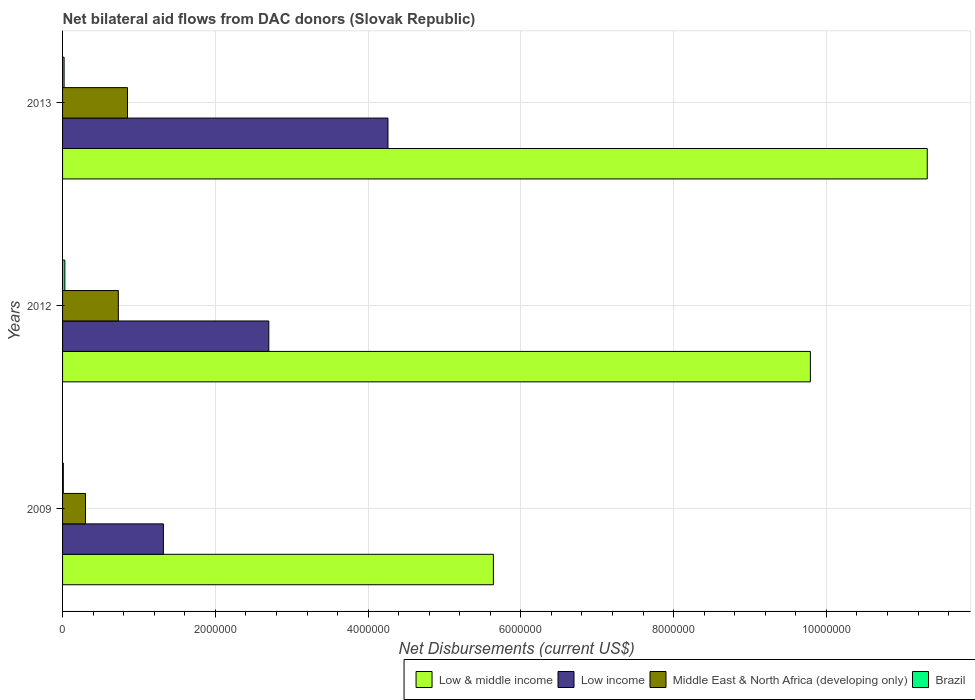How many different coloured bars are there?
Offer a very short reply. 4. Are the number of bars per tick equal to the number of legend labels?
Your answer should be compact. Yes. Are the number of bars on each tick of the Y-axis equal?
Ensure brevity in your answer.  Yes. How many bars are there on the 3rd tick from the bottom?
Keep it short and to the point. 4. In how many cases, is the number of bars for a given year not equal to the number of legend labels?
Keep it short and to the point. 0. What is the net bilateral aid flows in Low & middle income in 2012?
Offer a terse response. 9.79e+06. Across all years, what is the maximum net bilateral aid flows in Middle East & North Africa (developing only)?
Provide a short and direct response. 8.50e+05. Across all years, what is the minimum net bilateral aid flows in Low & middle income?
Your answer should be very brief. 5.64e+06. What is the total net bilateral aid flows in Low & middle income in the graph?
Provide a short and direct response. 2.68e+07. What is the difference between the net bilateral aid flows in Middle East & North Africa (developing only) in 2009 and that in 2013?
Your response must be concise. -5.50e+05. What is the difference between the net bilateral aid flows in Middle East & North Africa (developing only) in 2009 and the net bilateral aid flows in Brazil in 2013?
Provide a succinct answer. 2.80e+05. What is the average net bilateral aid flows in Low & middle income per year?
Offer a very short reply. 8.92e+06. In the year 2013, what is the difference between the net bilateral aid flows in Middle East & North Africa (developing only) and net bilateral aid flows in Low income?
Your answer should be compact. -3.41e+06. In how many years, is the net bilateral aid flows in Middle East & North Africa (developing only) greater than 9600000 US$?
Give a very brief answer. 0. What is the ratio of the net bilateral aid flows in Low income in 2009 to that in 2012?
Keep it short and to the point. 0.49. Is the net bilateral aid flows in Low income in 2009 less than that in 2013?
Offer a very short reply. Yes. What is the difference between the highest and the second highest net bilateral aid flows in Low income?
Provide a succinct answer. 1.56e+06. What is the difference between the highest and the lowest net bilateral aid flows in Low income?
Offer a terse response. 2.94e+06. In how many years, is the net bilateral aid flows in Middle East & North Africa (developing only) greater than the average net bilateral aid flows in Middle East & North Africa (developing only) taken over all years?
Offer a very short reply. 2. Is the sum of the net bilateral aid flows in Low & middle income in 2012 and 2013 greater than the maximum net bilateral aid flows in Middle East & North Africa (developing only) across all years?
Make the answer very short. Yes. What does the 4th bar from the bottom in 2013 represents?
Offer a very short reply. Brazil. Is it the case that in every year, the sum of the net bilateral aid flows in Middle East & North Africa (developing only) and net bilateral aid flows in Low income is greater than the net bilateral aid flows in Low & middle income?
Make the answer very short. No. How many bars are there?
Ensure brevity in your answer.  12. Are all the bars in the graph horizontal?
Your answer should be compact. Yes. What is the difference between two consecutive major ticks on the X-axis?
Your answer should be compact. 2.00e+06. Are the values on the major ticks of X-axis written in scientific E-notation?
Offer a terse response. No. Does the graph contain any zero values?
Offer a very short reply. No. Does the graph contain grids?
Provide a succinct answer. Yes. Where does the legend appear in the graph?
Offer a very short reply. Bottom right. What is the title of the graph?
Offer a very short reply. Net bilateral aid flows from DAC donors (Slovak Republic). Does "Bahrain" appear as one of the legend labels in the graph?
Provide a short and direct response. No. What is the label or title of the X-axis?
Offer a terse response. Net Disbursements (current US$). What is the Net Disbursements (current US$) of Low & middle income in 2009?
Provide a succinct answer. 5.64e+06. What is the Net Disbursements (current US$) in Low income in 2009?
Make the answer very short. 1.32e+06. What is the Net Disbursements (current US$) of Middle East & North Africa (developing only) in 2009?
Give a very brief answer. 3.00e+05. What is the Net Disbursements (current US$) in Low & middle income in 2012?
Make the answer very short. 9.79e+06. What is the Net Disbursements (current US$) of Low income in 2012?
Make the answer very short. 2.70e+06. What is the Net Disbursements (current US$) in Middle East & North Africa (developing only) in 2012?
Offer a terse response. 7.30e+05. What is the Net Disbursements (current US$) of Low & middle income in 2013?
Offer a terse response. 1.13e+07. What is the Net Disbursements (current US$) of Low income in 2013?
Give a very brief answer. 4.26e+06. What is the Net Disbursements (current US$) of Middle East & North Africa (developing only) in 2013?
Provide a succinct answer. 8.50e+05. Across all years, what is the maximum Net Disbursements (current US$) in Low & middle income?
Offer a terse response. 1.13e+07. Across all years, what is the maximum Net Disbursements (current US$) in Low income?
Your response must be concise. 4.26e+06. Across all years, what is the maximum Net Disbursements (current US$) in Middle East & North Africa (developing only)?
Offer a very short reply. 8.50e+05. Across all years, what is the minimum Net Disbursements (current US$) in Low & middle income?
Ensure brevity in your answer.  5.64e+06. Across all years, what is the minimum Net Disbursements (current US$) in Low income?
Keep it short and to the point. 1.32e+06. Across all years, what is the minimum Net Disbursements (current US$) in Brazil?
Your answer should be very brief. 10000. What is the total Net Disbursements (current US$) in Low & middle income in the graph?
Your answer should be compact. 2.68e+07. What is the total Net Disbursements (current US$) in Low income in the graph?
Keep it short and to the point. 8.28e+06. What is the total Net Disbursements (current US$) of Middle East & North Africa (developing only) in the graph?
Offer a terse response. 1.88e+06. What is the difference between the Net Disbursements (current US$) in Low & middle income in 2009 and that in 2012?
Your answer should be compact. -4.15e+06. What is the difference between the Net Disbursements (current US$) of Low income in 2009 and that in 2012?
Offer a terse response. -1.38e+06. What is the difference between the Net Disbursements (current US$) of Middle East & North Africa (developing only) in 2009 and that in 2012?
Offer a very short reply. -4.30e+05. What is the difference between the Net Disbursements (current US$) in Brazil in 2009 and that in 2012?
Ensure brevity in your answer.  -2.00e+04. What is the difference between the Net Disbursements (current US$) of Low & middle income in 2009 and that in 2013?
Keep it short and to the point. -5.68e+06. What is the difference between the Net Disbursements (current US$) of Low income in 2009 and that in 2013?
Ensure brevity in your answer.  -2.94e+06. What is the difference between the Net Disbursements (current US$) in Middle East & North Africa (developing only) in 2009 and that in 2013?
Offer a terse response. -5.50e+05. What is the difference between the Net Disbursements (current US$) in Low & middle income in 2012 and that in 2013?
Your answer should be compact. -1.53e+06. What is the difference between the Net Disbursements (current US$) of Low income in 2012 and that in 2013?
Your response must be concise. -1.56e+06. What is the difference between the Net Disbursements (current US$) of Middle East & North Africa (developing only) in 2012 and that in 2013?
Provide a short and direct response. -1.20e+05. What is the difference between the Net Disbursements (current US$) in Low & middle income in 2009 and the Net Disbursements (current US$) in Low income in 2012?
Make the answer very short. 2.94e+06. What is the difference between the Net Disbursements (current US$) in Low & middle income in 2009 and the Net Disbursements (current US$) in Middle East & North Africa (developing only) in 2012?
Provide a short and direct response. 4.91e+06. What is the difference between the Net Disbursements (current US$) in Low & middle income in 2009 and the Net Disbursements (current US$) in Brazil in 2012?
Your response must be concise. 5.61e+06. What is the difference between the Net Disbursements (current US$) of Low income in 2009 and the Net Disbursements (current US$) of Middle East & North Africa (developing only) in 2012?
Give a very brief answer. 5.90e+05. What is the difference between the Net Disbursements (current US$) of Low income in 2009 and the Net Disbursements (current US$) of Brazil in 2012?
Offer a very short reply. 1.29e+06. What is the difference between the Net Disbursements (current US$) in Low & middle income in 2009 and the Net Disbursements (current US$) in Low income in 2013?
Your answer should be compact. 1.38e+06. What is the difference between the Net Disbursements (current US$) in Low & middle income in 2009 and the Net Disbursements (current US$) in Middle East & North Africa (developing only) in 2013?
Keep it short and to the point. 4.79e+06. What is the difference between the Net Disbursements (current US$) of Low & middle income in 2009 and the Net Disbursements (current US$) of Brazil in 2013?
Your answer should be compact. 5.62e+06. What is the difference between the Net Disbursements (current US$) of Low income in 2009 and the Net Disbursements (current US$) of Middle East & North Africa (developing only) in 2013?
Your answer should be very brief. 4.70e+05. What is the difference between the Net Disbursements (current US$) of Low income in 2009 and the Net Disbursements (current US$) of Brazil in 2013?
Make the answer very short. 1.30e+06. What is the difference between the Net Disbursements (current US$) of Low & middle income in 2012 and the Net Disbursements (current US$) of Low income in 2013?
Offer a terse response. 5.53e+06. What is the difference between the Net Disbursements (current US$) of Low & middle income in 2012 and the Net Disbursements (current US$) of Middle East & North Africa (developing only) in 2013?
Your response must be concise. 8.94e+06. What is the difference between the Net Disbursements (current US$) in Low & middle income in 2012 and the Net Disbursements (current US$) in Brazil in 2013?
Provide a short and direct response. 9.77e+06. What is the difference between the Net Disbursements (current US$) in Low income in 2012 and the Net Disbursements (current US$) in Middle East & North Africa (developing only) in 2013?
Your response must be concise. 1.85e+06. What is the difference between the Net Disbursements (current US$) of Low income in 2012 and the Net Disbursements (current US$) of Brazil in 2013?
Provide a short and direct response. 2.68e+06. What is the difference between the Net Disbursements (current US$) of Middle East & North Africa (developing only) in 2012 and the Net Disbursements (current US$) of Brazil in 2013?
Provide a short and direct response. 7.10e+05. What is the average Net Disbursements (current US$) of Low & middle income per year?
Ensure brevity in your answer.  8.92e+06. What is the average Net Disbursements (current US$) in Low income per year?
Your response must be concise. 2.76e+06. What is the average Net Disbursements (current US$) in Middle East & North Africa (developing only) per year?
Your answer should be compact. 6.27e+05. In the year 2009, what is the difference between the Net Disbursements (current US$) of Low & middle income and Net Disbursements (current US$) of Low income?
Make the answer very short. 4.32e+06. In the year 2009, what is the difference between the Net Disbursements (current US$) in Low & middle income and Net Disbursements (current US$) in Middle East & North Africa (developing only)?
Keep it short and to the point. 5.34e+06. In the year 2009, what is the difference between the Net Disbursements (current US$) in Low & middle income and Net Disbursements (current US$) in Brazil?
Ensure brevity in your answer.  5.63e+06. In the year 2009, what is the difference between the Net Disbursements (current US$) in Low income and Net Disbursements (current US$) in Middle East & North Africa (developing only)?
Offer a very short reply. 1.02e+06. In the year 2009, what is the difference between the Net Disbursements (current US$) of Low income and Net Disbursements (current US$) of Brazil?
Ensure brevity in your answer.  1.31e+06. In the year 2012, what is the difference between the Net Disbursements (current US$) of Low & middle income and Net Disbursements (current US$) of Low income?
Keep it short and to the point. 7.09e+06. In the year 2012, what is the difference between the Net Disbursements (current US$) of Low & middle income and Net Disbursements (current US$) of Middle East & North Africa (developing only)?
Offer a very short reply. 9.06e+06. In the year 2012, what is the difference between the Net Disbursements (current US$) in Low & middle income and Net Disbursements (current US$) in Brazil?
Give a very brief answer. 9.76e+06. In the year 2012, what is the difference between the Net Disbursements (current US$) in Low income and Net Disbursements (current US$) in Middle East & North Africa (developing only)?
Your response must be concise. 1.97e+06. In the year 2012, what is the difference between the Net Disbursements (current US$) of Low income and Net Disbursements (current US$) of Brazil?
Keep it short and to the point. 2.67e+06. In the year 2013, what is the difference between the Net Disbursements (current US$) of Low & middle income and Net Disbursements (current US$) of Low income?
Provide a short and direct response. 7.06e+06. In the year 2013, what is the difference between the Net Disbursements (current US$) of Low & middle income and Net Disbursements (current US$) of Middle East & North Africa (developing only)?
Offer a very short reply. 1.05e+07. In the year 2013, what is the difference between the Net Disbursements (current US$) in Low & middle income and Net Disbursements (current US$) in Brazil?
Your answer should be very brief. 1.13e+07. In the year 2013, what is the difference between the Net Disbursements (current US$) in Low income and Net Disbursements (current US$) in Middle East & North Africa (developing only)?
Give a very brief answer. 3.41e+06. In the year 2013, what is the difference between the Net Disbursements (current US$) of Low income and Net Disbursements (current US$) of Brazil?
Your response must be concise. 4.24e+06. In the year 2013, what is the difference between the Net Disbursements (current US$) of Middle East & North Africa (developing only) and Net Disbursements (current US$) of Brazil?
Make the answer very short. 8.30e+05. What is the ratio of the Net Disbursements (current US$) of Low & middle income in 2009 to that in 2012?
Provide a short and direct response. 0.58. What is the ratio of the Net Disbursements (current US$) in Low income in 2009 to that in 2012?
Give a very brief answer. 0.49. What is the ratio of the Net Disbursements (current US$) in Middle East & North Africa (developing only) in 2009 to that in 2012?
Your answer should be very brief. 0.41. What is the ratio of the Net Disbursements (current US$) of Brazil in 2009 to that in 2012?
Give a very brief answer. 0.33. What is the ratio of the Net Disbursements (current US$) in Low & middle income in 2009 to that in 2013?
Your answer should be compact. 0.5. What is the ratio of the Net Disbursements (current US$) of Low income in 2009 to that in 2013?
Ensure brevity in your answer.  0.31. What is the ratio of the Net Disbursements (current US$) in Middle East & North Africa (developing only) in 2009 to that in 2013?
Your answer should be very brief. 0.35. What is the ratio of the Net Disbursements (current US$) of Low & middle income in 2012 to that in 2013?
Make the answer very short. 0.86. What is the ratio of the Net Disbursements (current US$) in Low income in 2012 to that in 2013?
Give a very brief answer. 0.63. What is the ratio of the Net Disbursements (current US$) of Middle East & North Africa (developing only) in 2012 to that in 2013?
Give a very brief answer. 0.86. What is the difference between the highest and the second highest Net Disbursements (current US$) in Low & middle income?
Your answer should be compact. 1.53e+06. What is the difference between the highest and the second highest Net Disbursements (current US$) in Low income?
Your response must be concise. 1.56e+06. What is the difference between the highest and the second highest Net Disbursements (current US$) in Middle East & North Africa (developing only)?
Make the answer very short. 1.20e+05. What is the difference between the highest and the second highest Net Disbursements (current US$) of Brazil?
Give a very brief answer. 10000. What is the difference between the highest and the lowest Net Disbursements (current US$) of Low & middle income?
Your response must be concise. 5.68e+06. What is the difference between the highest and the lowest Net Disbursements (current US$) in Low income?
Your response must be concise. 2.94e+06. What is the difference between the highest and the lowest Net Disbursements (current US$) in Middle East & North Africa (developing only)?
Ensure brevity in your answer.  5.50e+05. 